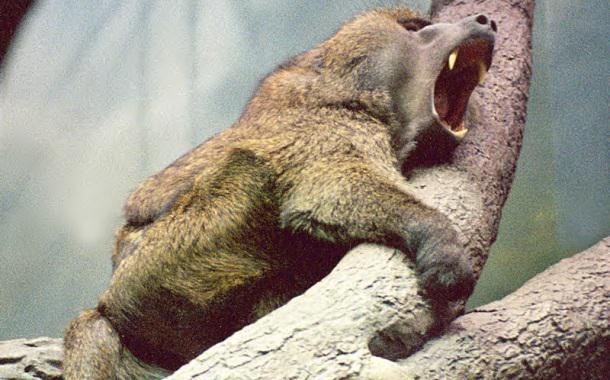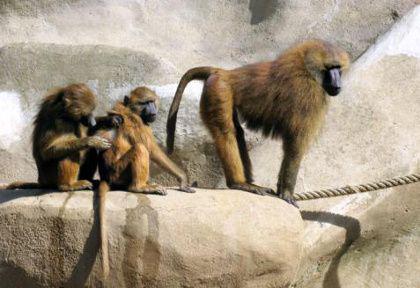The first image is the image on the left, the second image is the image on the right. Assess this claim about the two images: "An image includes one adult monkey on the right, and two sitting same-size juvenile monkeys on the left.". Correct or not? Answer yes or no. Yes. The first image is the image on the left, the second image is the image on the right. Evaluate the accuracy of this statement regarding the images: "There are at most 4 monkeys in total". Is it true? Answer yes or no. Yes. 